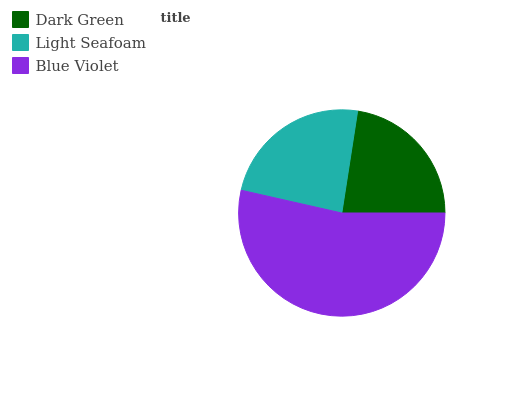Is Dark Green the minimum?
Answer yes or no. Yes. Is Blue Violet the maximum?
Answer yes or no. Yes. Is Light Seafoam the minimum?
Answer yes or no. No. Is Light Seafoam the maximum?
Answer yes or no. No. Is Light Seafoam greater than Dark Green?
Answer yes or no. Yes. Is Dark Green less than Light Seafoam?
Answer yes or no. Yes. Is Dark Green greater than Light Seafoam?
Answer yes or no. No. Is Light Seafoam less than Dark Green?
Answer yes or no. No. Is Light Seafoam the high median?
Answer yes or no. Yes. Is Light Seafoam the low median?
Answer yes or no. Yes. Is Dark Green the high median?
Answer yes or no. No. Is Blue Violet the low median?
Answer yes or no. No. 